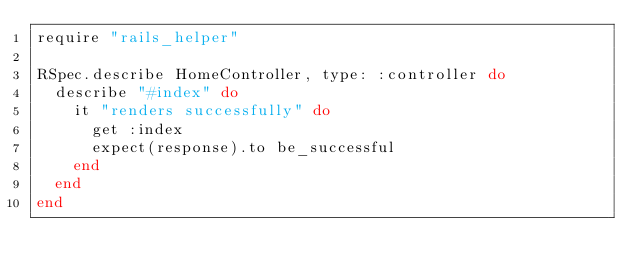<code> <loc_0><loc_0><loc_500><loc_500><_Ruby_>require "rails_helper"

RSpec.describe HomeController, type: :controller do
  describe "#index" do
    it "renders successfully" do
      get :index
      expect(response).to be_successful
    end
  end
end
</code> 